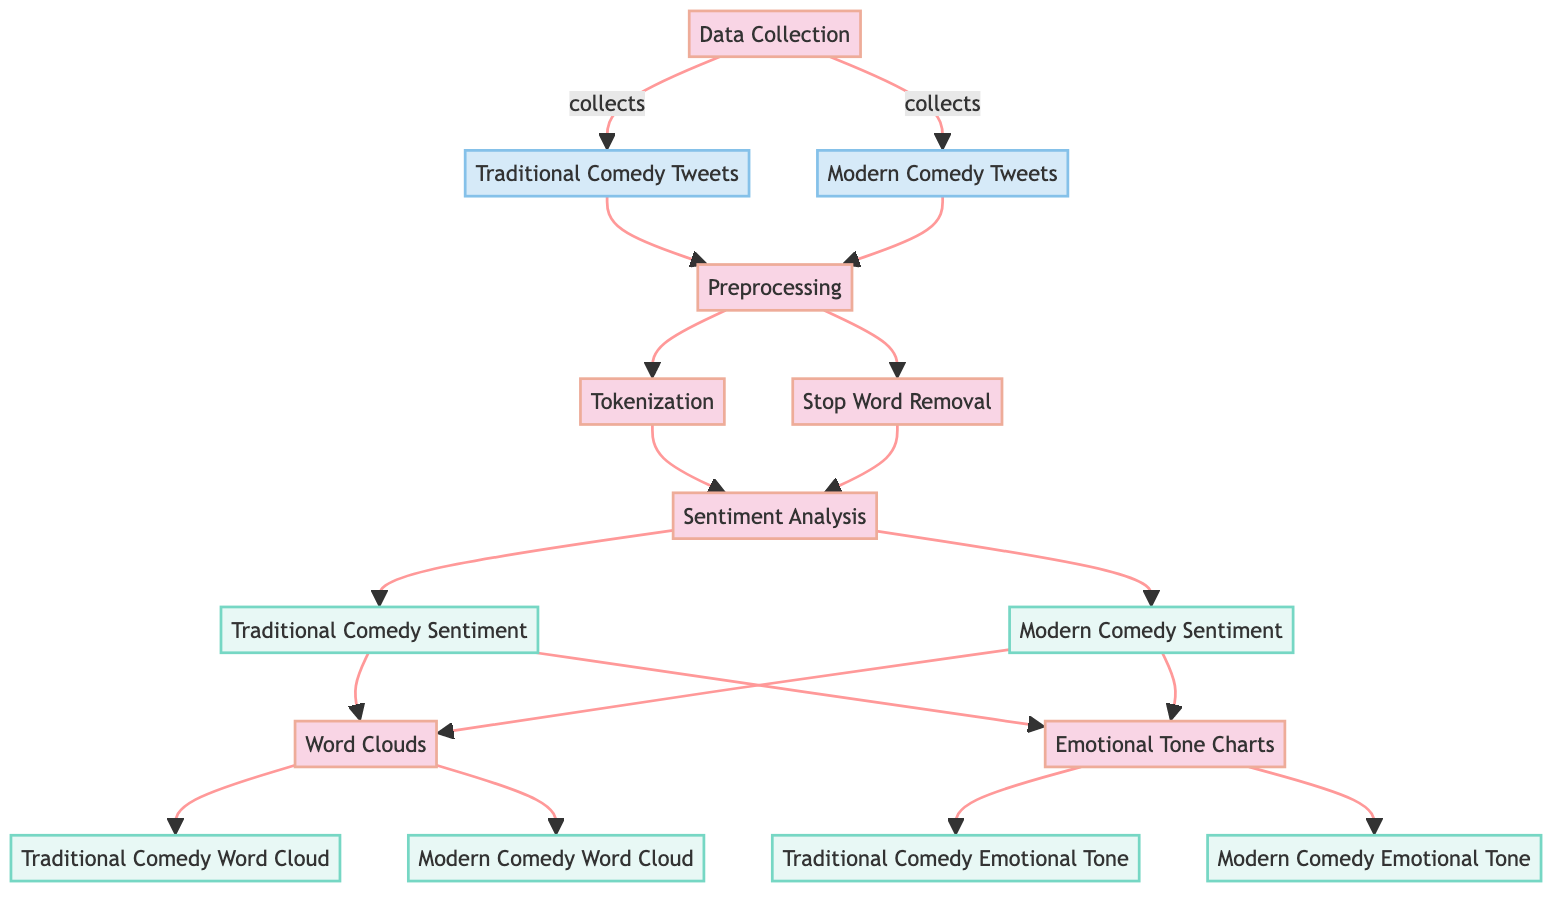What are the types of tweets collected in the diagram? The diagram shows two types of tweets: Traditional Comedy Tweets and Modern Comedy Tweets, which are represented as nodes under the Data Collection process.
Answer: Traditional Comedy Tweets and Modern Comedy Tweets What is the first process in the diagram? The diagram begins with the Data Collection process, which is the starting point before any preprocessing is done.
Answer: Data Collection How many output nodes are there in total? By counting the output nodes, we find that there are a total of four (Traditional Comedy Sentiment, Modern Comedy Sentiment, Traditional Comedy Word Cloud, Modern Comedy Word Cloud, Traditional Comedy Emotional Tone, Modern Comedy Emotional Tone).
Answer: Six Which step follows the Preprocessing node? After the Preprocessing node, the next step in the flow is the Sentiment Analysis node that takes the output from the preprocessing stage.
Answer: Sentiment Analysis What is indicated by the connection between Sentiment Analysis and Word Clouds? The connection signifies that the sentiment analysis results (traditional and modern comedy sentiments) lead to the generation of word clouds for both types of comedy, representing the data visually.
Answer: Word Clouds What is the function of the Tokenization step? Tokenization is part of the preprocessing phase where the text is split into individual words or phrases, preparing the data for further analysis in the next step.
Answer: Prepare data for analysis Which emotional tone charts correlate with sentiment analysis? Each sentiment analysis for traditional and modern comedy is followed by the creation of emotional tone charts that provide a visual representation of the emotional aspects of the tweets analyzed.
Answer: Traditional Comedy Emotional Tone and Modern Comedy Emotional Tone How do Traditional Comedy Tweets enter the process? Traditional Comedy Tweets are collected as input in the Data Collection process, which then moves towards preprocessing before any analysis occurs.
Answer: Collected in Data Collection In the diagram, which two nodes are connected to the output of Sentiment Analysis? The output from the Sentiment Analysis node connects to both the Traditional Comedy Sentiment and the Modern Comedy Sentiment nodes, showing separate outputs for each type of comedy analyzed.
Answer: Traditional Comedy Sentiment and Modern Comedy Sentiment 